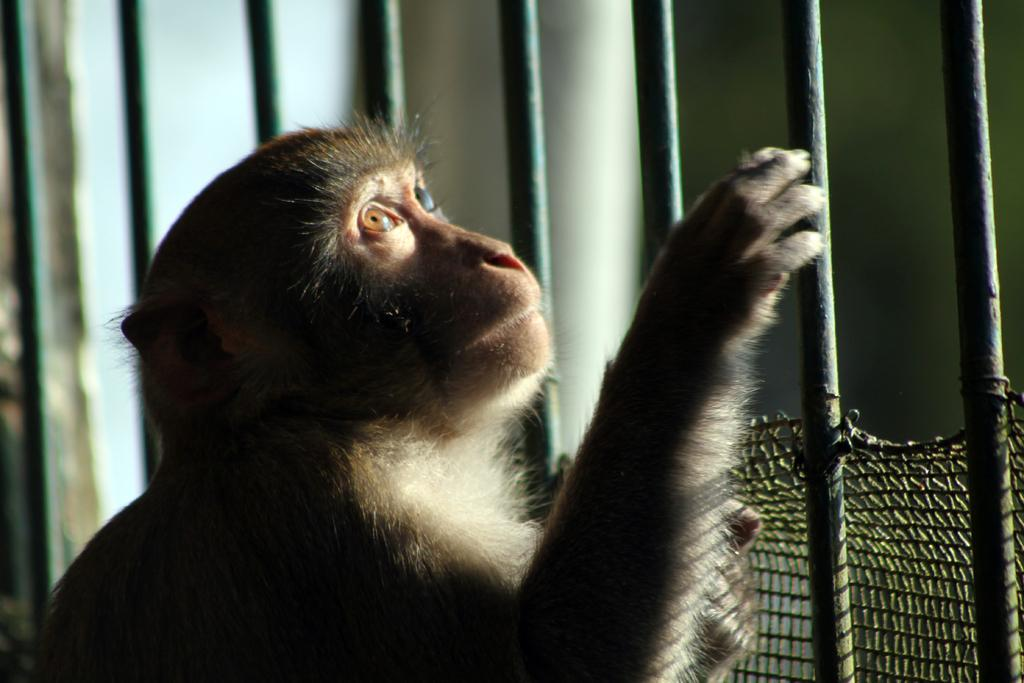What animal is present in the image? There is a monkey in the picture. Where is the monkey located in relation to the railing? The monkey is near the railing. What direction is the monkey looking in the image? The monkey is looking upwards. What type of structure is attached to the railing? There is a part of a net attached to the railing. What type of lace can be seen on the monkey's clothing in the image? There is no lace visible on the monkey's clothing in the image. Is there a shop visible in the background of the image? There is no shop visible in the image; it only features a monkey near a railing with a part of a net attached. 